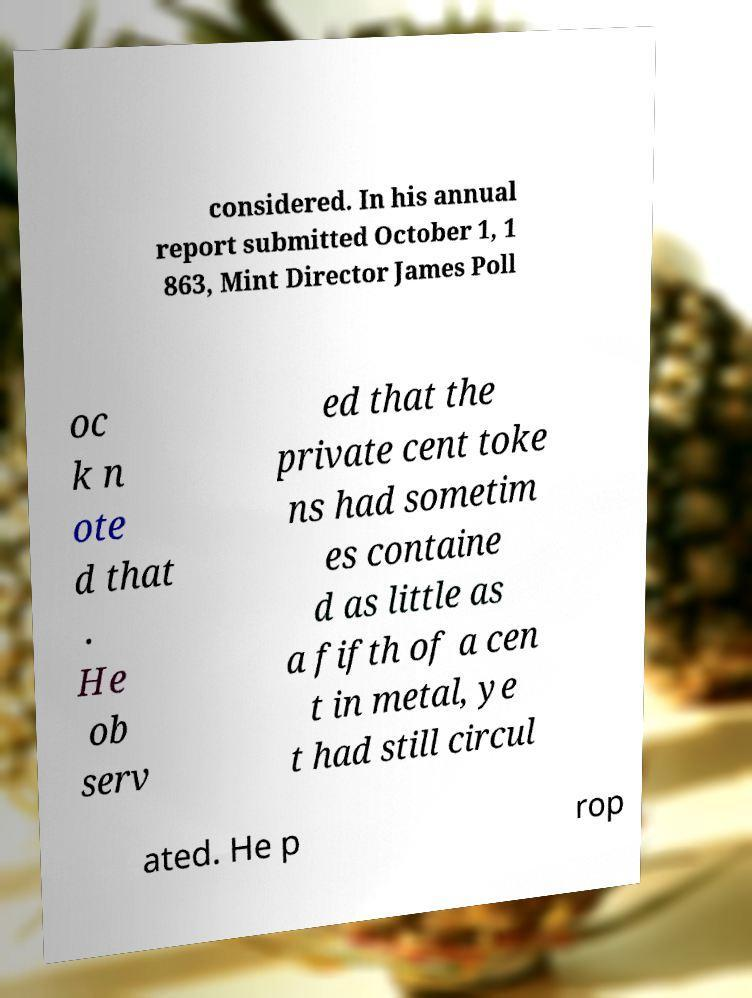Can you read and provide the text displayed in the image?This photo seems to have some interesting text. Can you extract and type it out for me? considered. In his annual report submitted October 1, 1 863, Mint Director James Poll oc k n ote d that . He ob serv ed that the private cent toke ns had sometim es containe d as little as a fifth of a cen t in metal, ye t had still circul ated. He p rop 